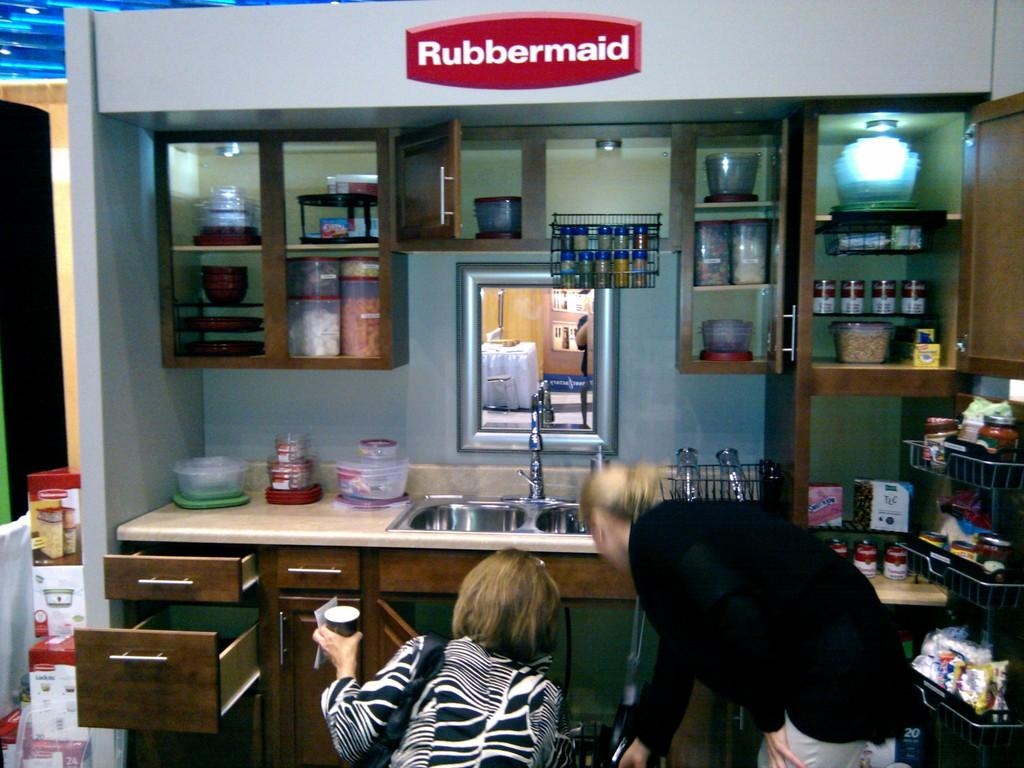<image>
Provide a brief description of the given image. A kitchen display setup with the word Rubbermaid on top. 